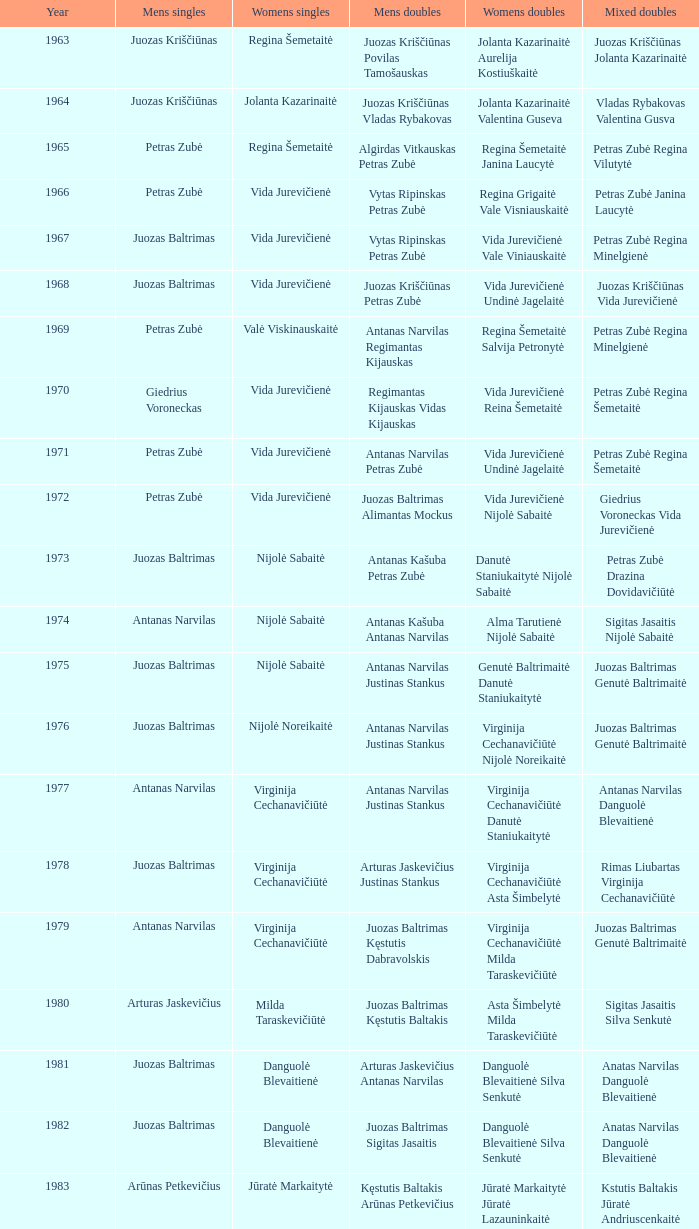How many years did aivaras kvedarauskas juozas spelveris take part in the men's doubles? 1.0. 